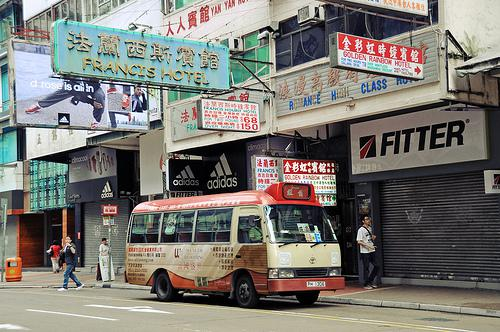Question: who is walking across the street?
Choices:
A. A child.
B. A policeman.
C. A walker.
D. Woman.
Answer with the letter. Answer: D Question: why is there an orange garbage can there?
Choices:
A. Trash.
B. To catch water.
C. To hold trash.
D. To throw stuff into.
Answer with the letter. Answer: A 